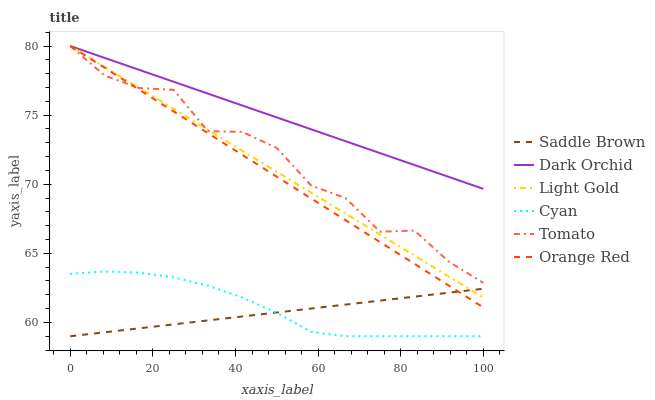Does Saddle Brown have the minimum area under the curve?
Answer yes or no. Yes. Does Dark Orchid have the maximum area under the curve?
Answer yes or no. Yes. Does Orange Red have the minimum area under the curve?
Answer yes or no. No. Does Orange Red have the maximum area under the curve?
Answer yes or no. No. Is Saddle Brown the smoothest?
Answer yes or no. Yes. Is Tomato the roughest?
Answer yes or no. Yes. Is Dark Orchid the smoothest?
Answer yes or no. No. Is Dark Orchid the roughest?
Answer yes or no. No. Does Orange Red have the lowest value?
Answer yes or no. No. Does Light Gold have the highest value?
Answer yes or no. Yes. Does Cyan have the highest value?
Answer yes or no. No. Is Saddle Brown less than Dark Orchid?
Answer yes or no. Yes. Is Dark Orchid greater than Saddle Brown?
Answer yes or no. Yes. Does Dark Orchid intersect Orange Red?
Answer yes or no. Yes. Is Dark Orchid less than Orange Red?
Answer yes or no. No. Is Dark Orchid greater than Orange Red?
Answer yes or no. No. Does Saddle Brown intersect Dark Orchid?
Answer yes or no. No. 